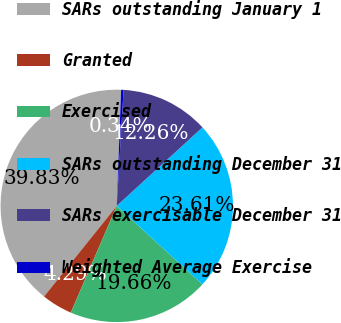Convert chart. <chart><loc_0><loc_0><loc_500><loc_500><pie_chart><fcel>SARs outstanding January 1<fcel>Granted<fcel>Exercised<fcel>SARs outstanding December 31<fcel>SARs exercisable December 31<fcel>Weighted Average Exercise<nl><fcel>39.83%<fcel>4.29%<fcel>19.66%<fcel>23.61%<fcel>12.26%<fcel>0.34%<nl></chart> 